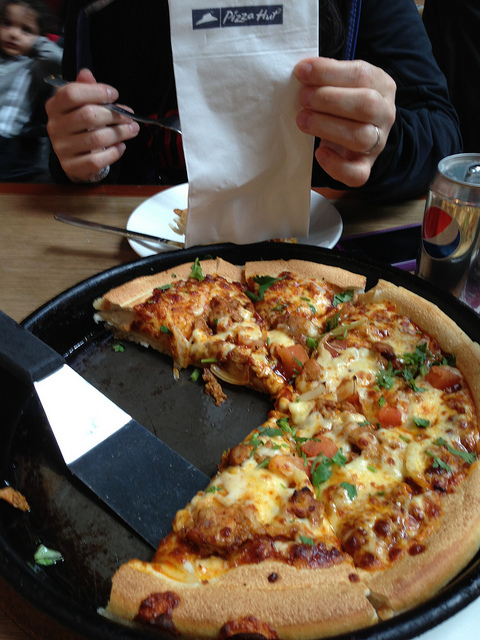Extract all visible text content from this image. Pizza Hut 